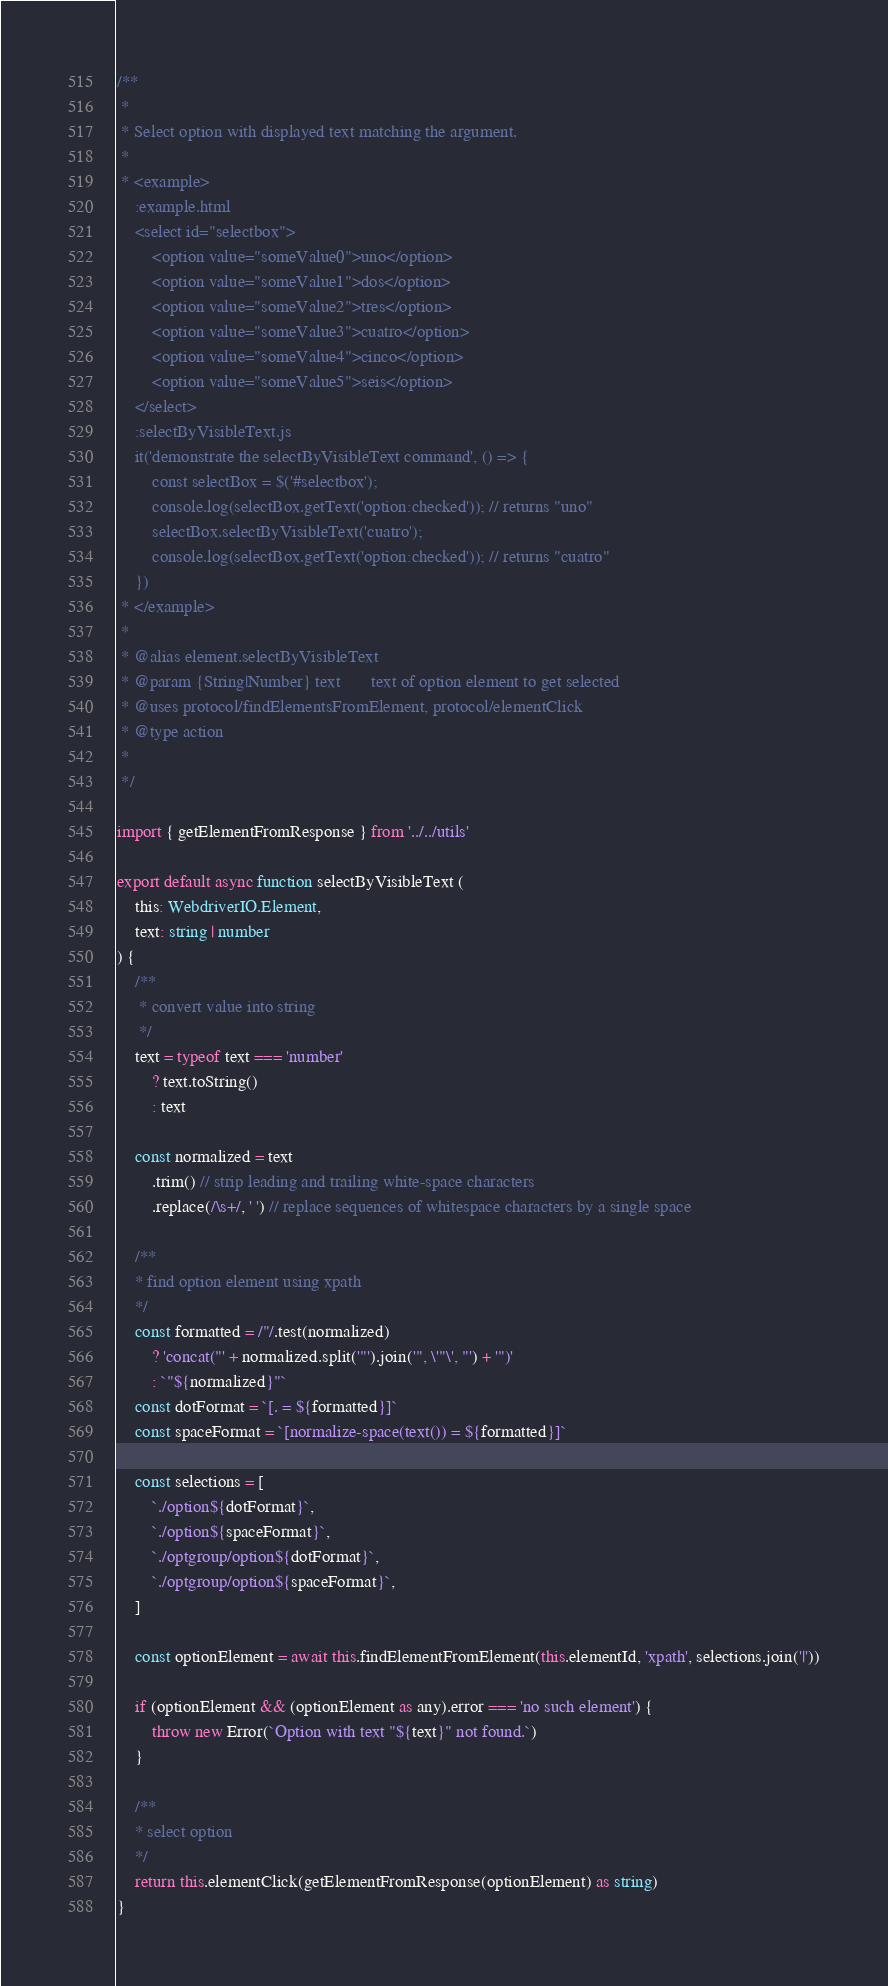<code> <loc_0><loc_0><loc_500><loc_500><_TypeScript_>/**
 *
 * Select option with displayed text matching the argument.
 *
 * <example>
    :example.html
    <select id="selectbox">
        <option value="someValue0">uno</option>
        <option value="someValue1">dos</option>
        <option value="someValue2">tres</option>
        <option value="someValue3">cuatro</option>
        <option value="someValue4">cinco</option>
        <option value="someValue5">seis</option>
    </select>
    :selectByVisibleText.js
    it('demonstrate the selectByVisibleText command', () => {
        const selectBox = $('#selectbox');
        console.log(selectBox.getText('option:checked')); // returns "uno"
        selectBox.selectByVisibleText('cuatro');
        console.log(selectBox.getText('option:checked')); // returns "cuatro"
    })
 * </example>
 *
 * @alias element.selectByVisibleText
 * @param {String|Number} text       text of option element to get selected
 * @uses protocol/findElementsFromElement, protocol/elementClick
 * @type action
 *
 */

import { getElementFromResponse } from '../../utils'

export default async function selectByVisibleText (
    this: WebdriverIO.Element,
    text: string | number
) {
    /**
     * convert value into string
     */
    text = typeof text === 'number'
        ? text.toString()
        : text

    const normalized = text
        .trim() // strip leading and trailing white-space characters
        .replace(/\s+/, ' ') // replace sequences of whitespace characters by a single space

    /**
    * find option element using xpath
    */
    const formatted = /"/.test(normalized)
        ? 'concat("' + normalized.split('"').join('", \'"\', "') + '")'
        : `"${normalized}"`
    const dotFormat = `[. = ${formatted}]`
    const spaceFormat = `[normalize-space(text()) = ${formatted}]`

    const selections = [
        `./option${dotFormat}`,
        `./option${spaceFormat}`,
        `./optgroup/option${dotFormat}`,
        `./optgroup/option${spaceFormat}`,
    ]

    const optionElement = await this.findElementFromElement(this.elementId, 'xpath', selections.join('|'))

    if (optionElement && (optionElement as any).error === 'no such element') {
        throw new Error(`Option with text "${text}" not found.`)
    }

    /**
    * select option
    */
    return this.elementClick(getElementFromResponse(optionElement) as string)
}
</code> 